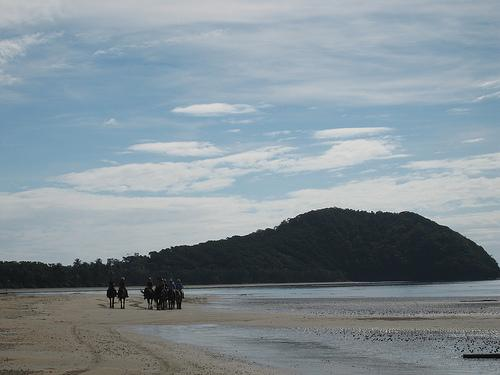Describe the environment and mood portrayed in this picture. In the image, a calm, picturesque beach scene is presented with horse riders exploring the shoreline, tranquil ocean waters, and serene green hill landscape under a vast, blue, cloud-dotted sky. Mention the natural components present in the image in one sentence. The image showcases a sandy beach, ocean waters, a green hill, and a cloudy blue sky as the main natural components. What are the main activities happening in the image? Horse riders are traveling the beach, while two horses stand side-by-side with noticeable tracks in the sand as a blue clouded sky and green hill set the scene. Enumerate the primary elements in the picture with respect to their colors. Blue cloudy sky, brown sand, green hill, tracks in sand, people on horses, and patches of debris on the beach. Recount the details of the sky as seen in the image. The sky in the image is mostly blue, populated by white clouds of varying sizes and shapes, adding an air of tranquility to the overall scene. Describe the location where this picture was captured, including surroundings. This picture was taken at a beach with soft brown sand, a vast ocean near it, and striking hills in the background under a blue, cloud-filled sky. Narrate a descriptive account of the major subjects in this photograph. In the photograph, riders on horses make their way along a sandy beach, leaving tracks behind, as a large, glistening ocean meets the scenic lush green hills, all underneath a vast blue sky speckled with fluffy white clouds. Explain the image in a way that emphasizes the beauty of nature. The stunning image captures the breathtaking beauty of a sandy beach with turquoise ocean waters, lush verdant hills, and a serene blue sky filled with soft, billowy clouds. Summarize the natural formations present in the image. The image features a blue sky with clouds, a sandy beach, ocean water, and a lush green hill in the background. Provide a concise description of the prominent elements in the image. People riding horses on a brown sandy beach, a large water body in the vicinity, lush green hills, and a blue cloudy sky above. 